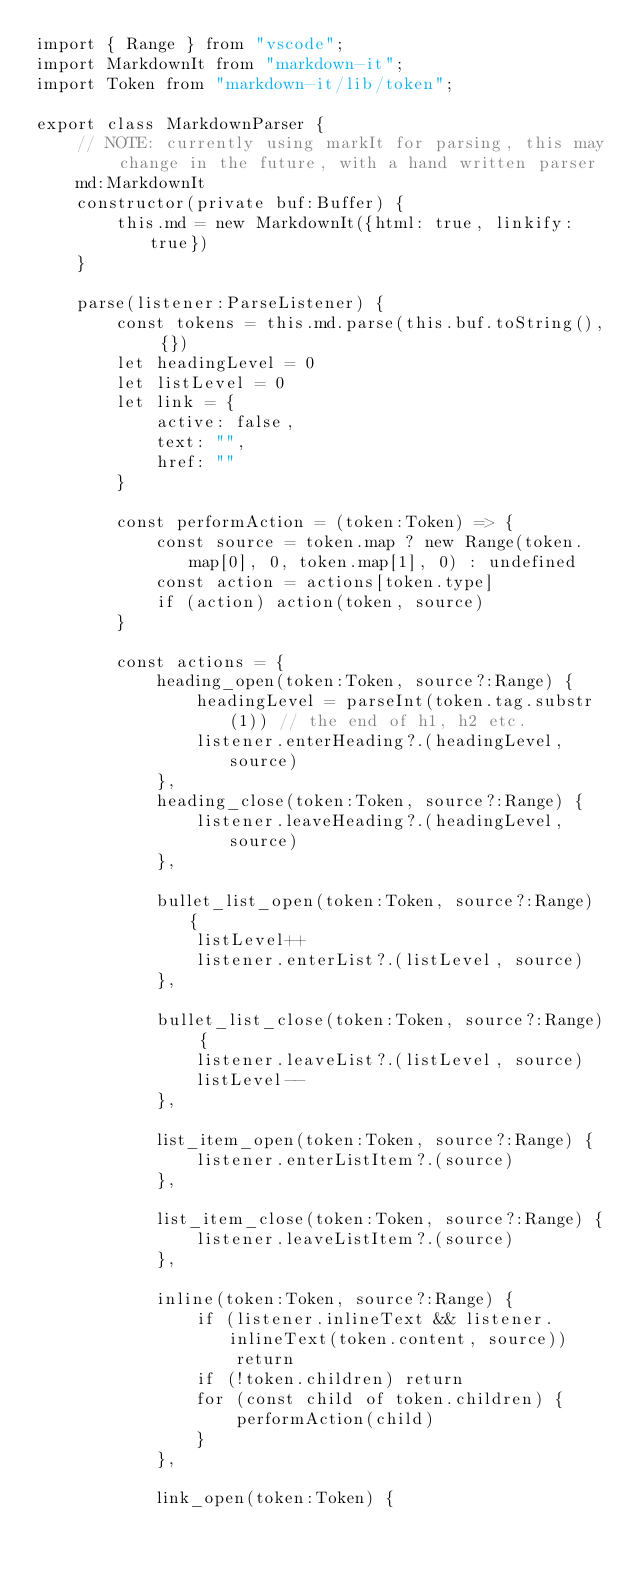<code> <loc_0><loc_0><loc_500><loc_500><_TypeScript_>import { Range } from "vscode";
import MarkdownIt from "markdown-it";
import Token from "markdown-it/lib/token";

export class MarkdownParser {
    // NOTE: currently using markIt for parsing, this may change in the future, with a hand written parser
    md:MarkdownIt
    constructor(private buf:Buffer) {
        this.md = new MarkdownIt({html: true, linkify:true})
    }

    parse(listener:ParseListener) {
        const tokens = this.md.parse(this.buf.toString(), {})
        let headingLevel = 0
        let listLevel = 0
        let link = {
            active: false,
            text: "",
            href: ""
        }

        const performAction = (token:Token) => {
            const source = token.map ? new Range(token.map[0], 0, token.map[1], 0) : undefined
            const action = actions[token.type]
            if (action) action(token, source)
        }

        const actions = {
            heading_open(token:Token, source?:Range) {
                headingLevel = parseInt(token.tag.substr(1)) // the end of h1, h2 etc.
                listener.enterHeading?.(headingLevel, source)
            },
            heading_close(token:Token, source?:Range) {
                listener.leaveHeading?.(headingLevel, source)
            },

            bullet_list_open(token:Token, source?:Range) {
                listLevel++
                listener.enterList?.(listLevel, source)
            },

            bullet_list_close(token:Token, source?:Range) {
                listener.leaveList?.(listLevel, source)
                listLevel--
            },

            list_item_open(token:Token, source?:Range) {
                listener.enterListItem?.(source)
            },

            list_item_close(token:Token, source?:Range) {
                listener.leaveListItem?.(source)
            },

            inline(token:Token, source?:Range) {
                if (listener.inlineText && listener.inlineText(token.content, source))
                    return
                if (!token.children) return
                for (const child of token.children) {
                    performAction(child)
                }
            },

            link_open(token:Token) {</code> 